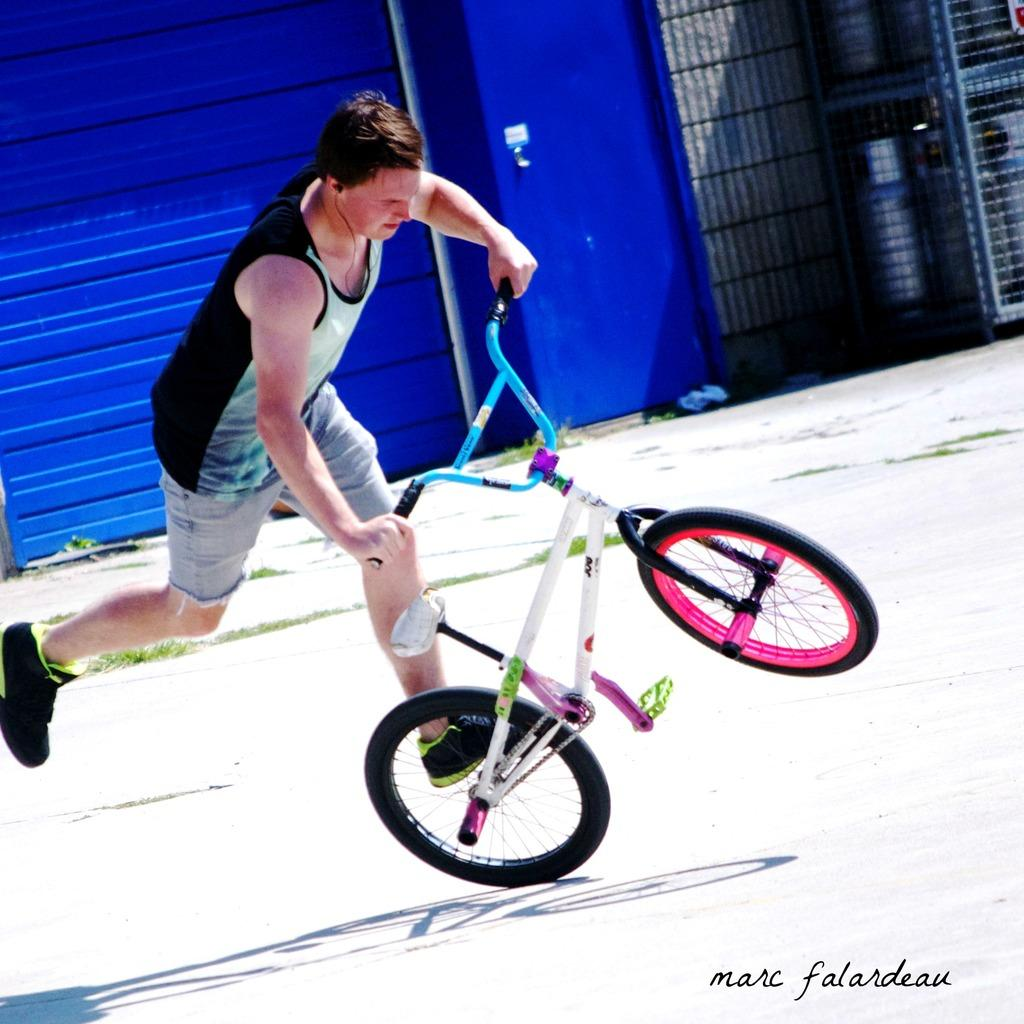Who is present in the image? There is a man in the image. What is the man doing in the image? The man is with a bicycle in the image. What type of terrain is visible in the image? There is grass visible in the image. What type of path is visible in the image? There is a road in the image. What type of barrier is visible in the image? There is a wall and a fence in the image. Where is the text located in the image? The text is in the bottom right corner of the image. What type of bait is the man using to catch fish in the image? There is no indication of fishing or bait in the image; the man is with a bicycle. What type of volleyball game is being played in the image? There is no volleyball game or any reference to volleyball in the image. 